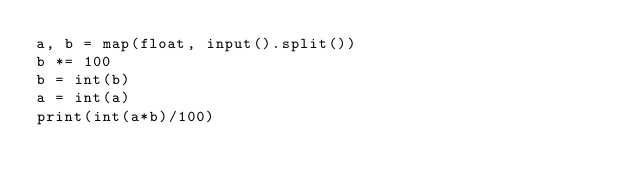Convert code to text. <code><loc_0><loc_0><loc_500><loc_500><_Python_>a, b = map(float, input().split())
b *= 100
b = int(b)
a = int(a)
print(int(a*b)/100)
</code> 